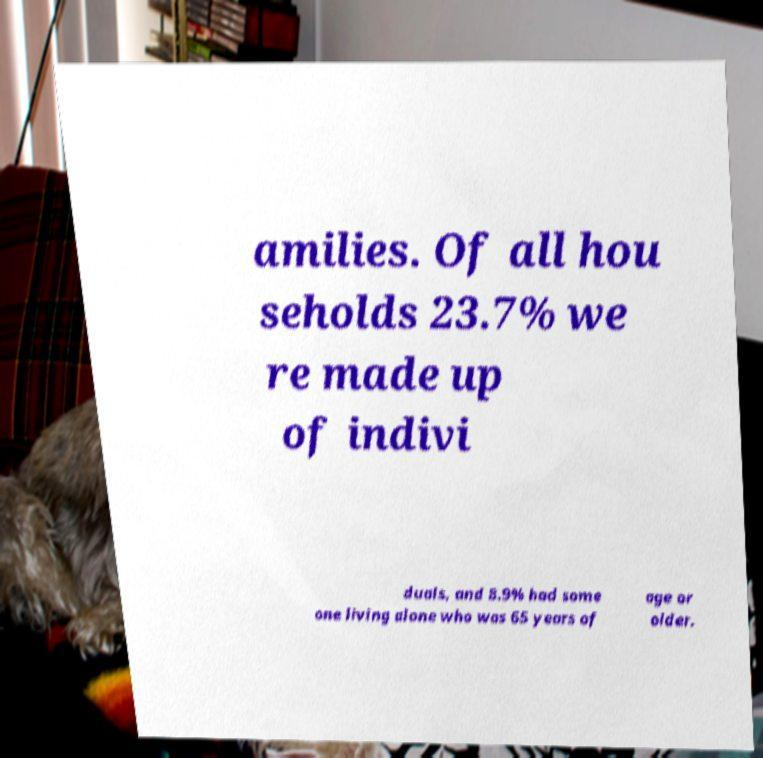Please identify and transcribe the text found in this image. amilies. Of all hou seholds 23.7% we re made up of indivi duals, and 8.9% had some one living alone who was 65 years of age or older. 